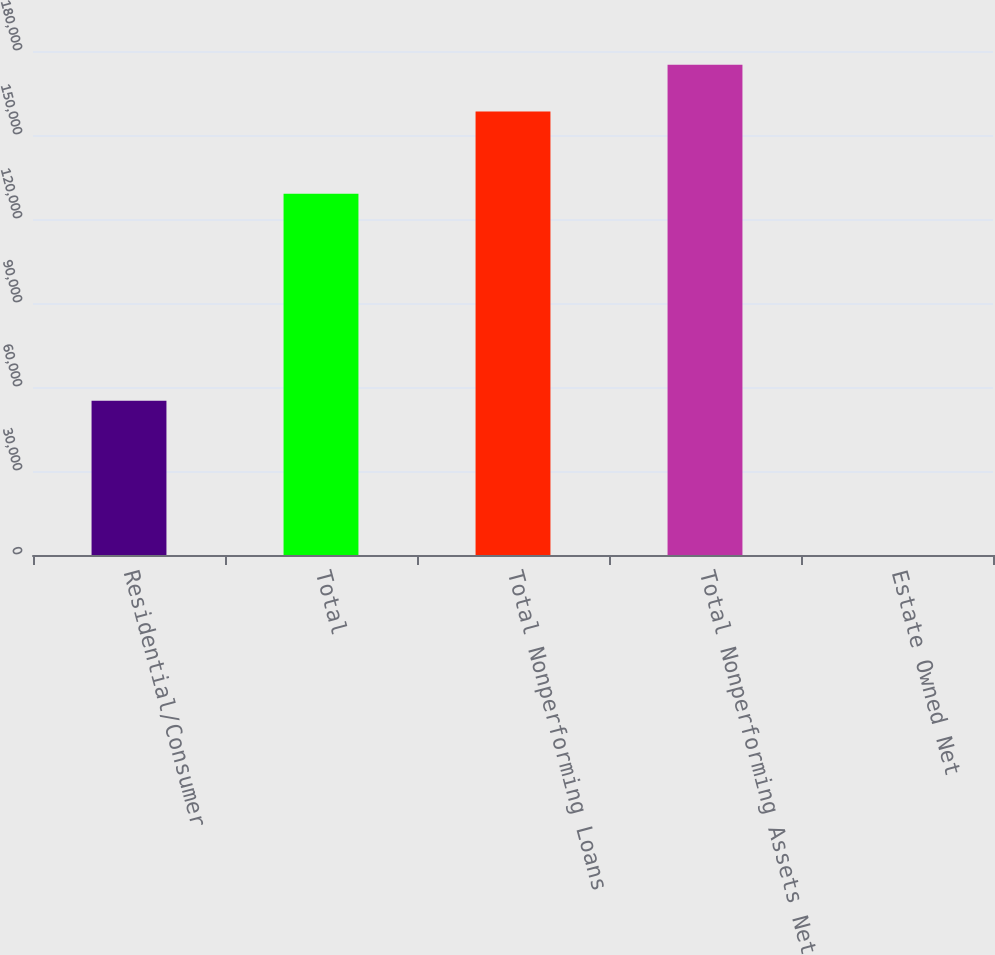Convert chart to OTSL. <chart><loc_0><loc_0><loc_500><loc_500><bar_chart><fcel>Residential/Consumer<fcel>Total<fcel>Total Nonperforming Loans<fcel>Total Nonperforming Assets Net<fcel>Estate Owned Net<nl><fcel>55097<fcel>129058<fcel>158382<fcel>175089<fcel>2.53<nl></chart> 